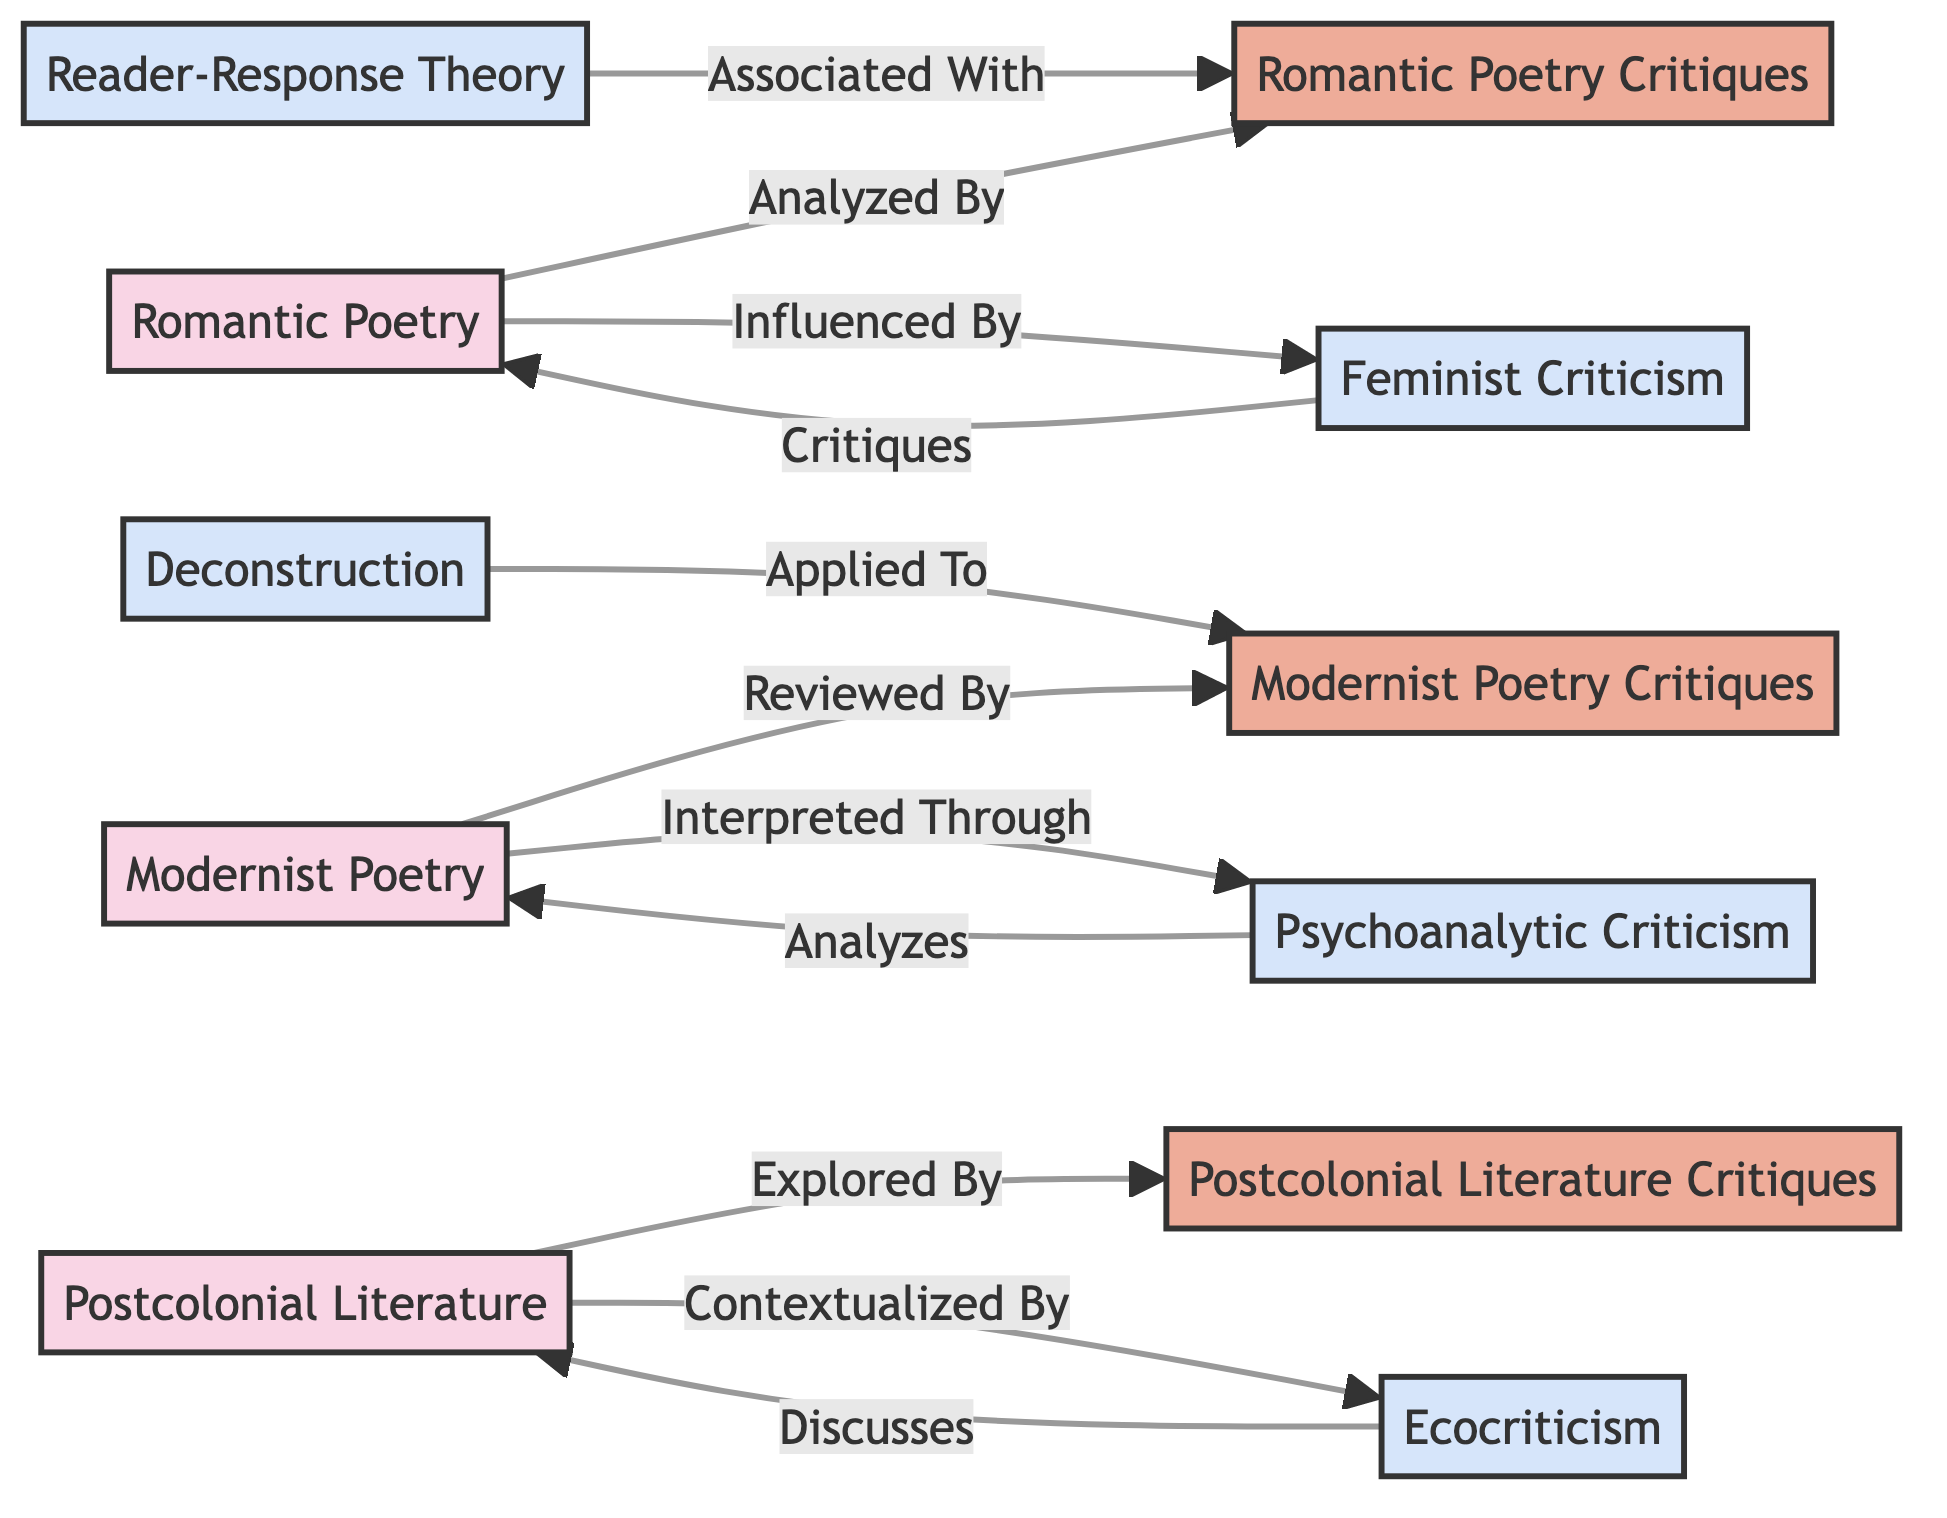What are the three major book topics represented in the diagram? The diagram includes three major book topics: Romantic Poetry, Modernist Poetry, and Postcolonial Literature. Each of these is represented as a distinct node in the graph.
Answer: Romantic Poetry, Modernist Poetry, Postcolonial Literature How many critiques are listed in the diagram? There are three critiques listed in the diagram: Romantic Poetry Critiques, Modernist Poetry Critiques, and Postcolonial Literature Critiques. Each critique is represented as a node associated with the major book topics.
Answer: 3 Which critique is associated with Reader-Response Theory? Reader-Response Theory is associated with Romantic Poetry Critiques, as indicated by the edge labeled "Associated With." This shows the relationship between the critique and the theory.
Answer: Romantic Poetry Critiques What type of theory interprets Modernist Poetry? Psychoanalytic Criticism is identified as the theory that interprets Modernist Poetry, indicated by the edge labeled "Interpreted Through."
Answer: Psychoanalytic Criticism Which book topic is influenced by Feminist Criticism? Romantic Poetry is influenced by Feminist Criticism, as shown by the edge labeled "Influenced By." This establishes the direction of influence from the theory to the topic.
Answer: Romantic Poetry How is Postcolonial Literature contextualized? Postcolonial Literature is contextualized by Ecocriticism, which is shown by the edge labeled "Contextualized By." This signifies the relationship that provides context to the literature through the theory.
Answer: Ecocriticism Which theory critiques Romantic Poetry? Feminist Criticism critiques Romantic Poetry, as indicated by the edge labeled "Critiques." This directly establishes which theory is interacting with the book topic.
Answer: Feminist Criticism What type of critique is explored in relation to Postcolonial Literature? Postcolonial Literature Critiques are explored in relation to Postcolonial Literature, directly connected by the edge labeled "Explored By."
Answer: Postcolonial Literature Critiques How many edges are present in the diagram? The diagram has a total of ten edges, which connect various book topics and critiques, illustrating the relationships among them.
Answer: 10 